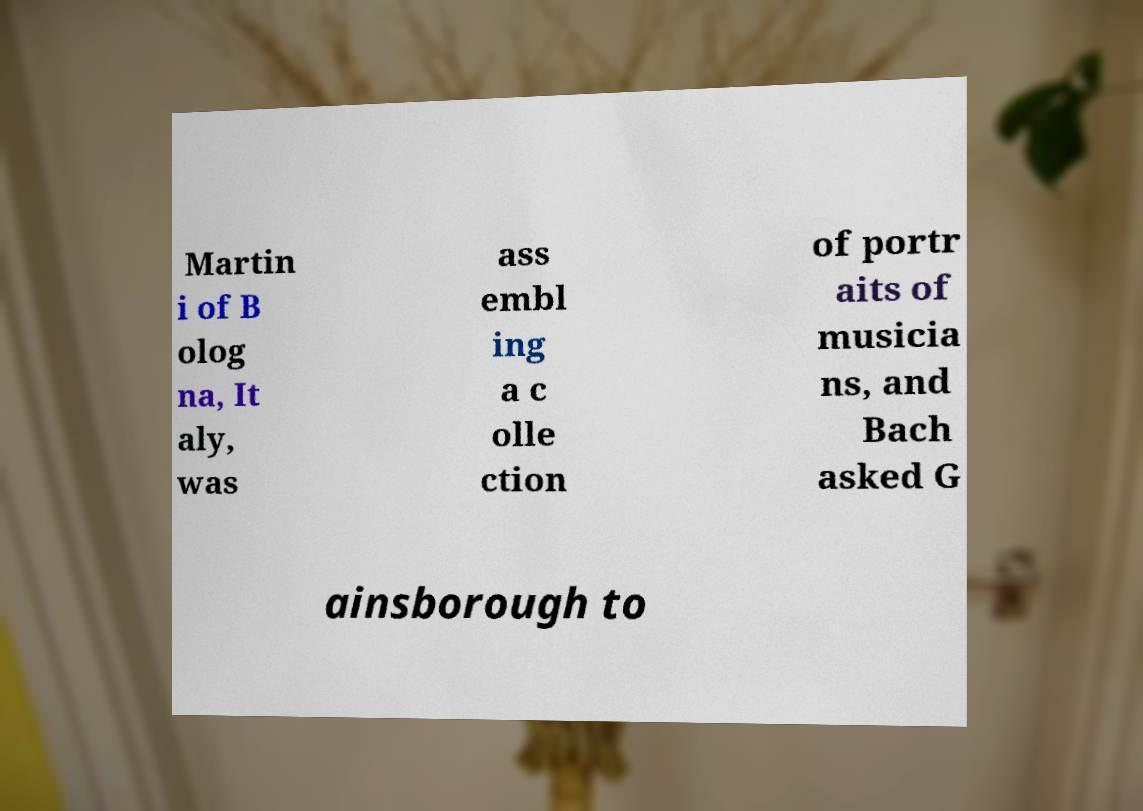Could you assist in decoding the text presented in this image and type it out clearly? Martin i of B olog na, It aly, was ass embl ing a c olle ction of portr aits of musicia ns, and Bach asked G ainsborough to 